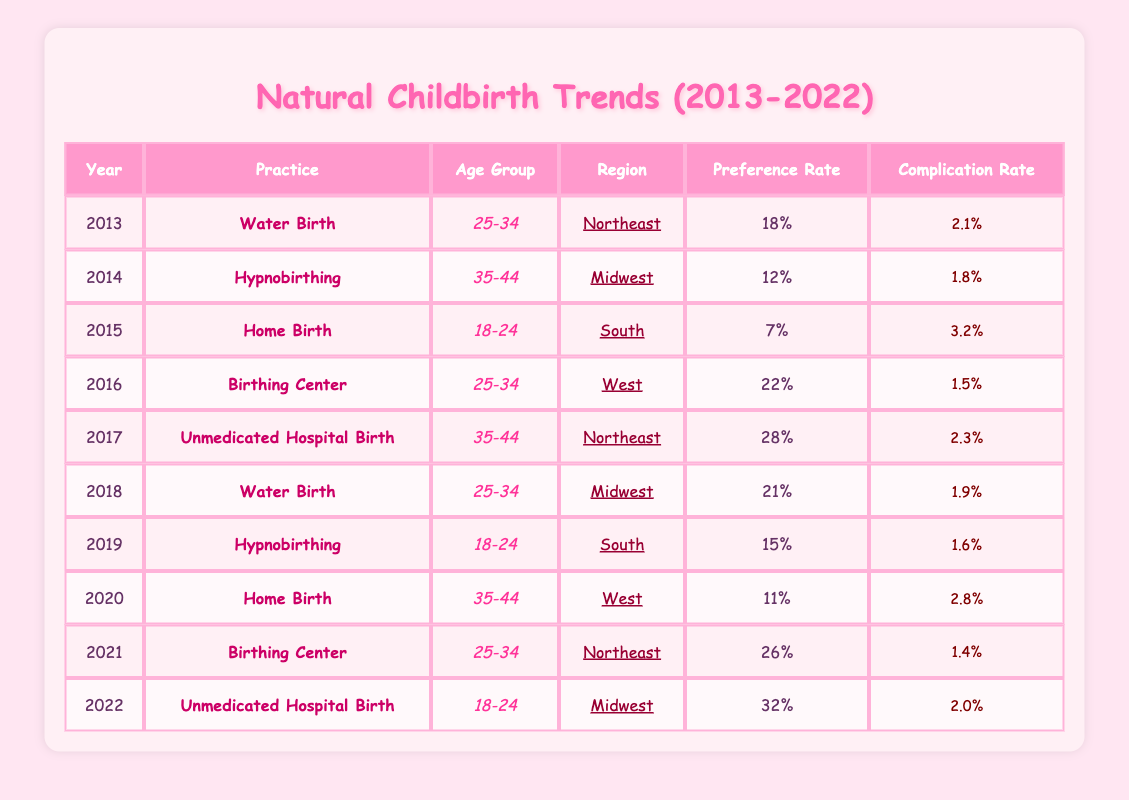What natural childbirth practice had the highest preference rate in 2022? The table shows that in 2022, the practice with the highest preference rate was Unmedicated Hospital Birth with a rate of 32.
Answer: Unmedicated Hospital Birth Which age group preferred Hypnobirthing in 2014? According to the table, Hypnobirthing was preferred by the age group 35-44 in 2014.
Answer: 35-44 How many practices had a preference rate of 20 or higher over the years? To find this, we check the preference rates for each practice from the table. The rates of 22 (2016), 28 (2017), 21 (2018), 26 (2021), and 32 (2022) qualify. This gives us a total of 5 practices.
Answer: 5 What was the complication rate for Home Birth in the year 2020? From the table, the complication rate for Home Birth in 2020 is listed as 2.8%.
Answer: 2.8% Did any of the Natural Childbirth practices show a decrease in preference rate from one year to the next? Checking the preference rates year by year, Home Birth decreased from 7 in 2015 to 11 in 2020, so that was not a decrease. However, Hypnobirthing decreased from 15 in 2019 to 12 in 2014, indicating a decrease over some years. Thus, yes, there were decreases in other practices, but none from 2015 to 2020.
Answer: Yes What was the average preference rate for Water Birth practices in the table? The preference rates for Water Birth are 18 (2013) and 21 (2018). Adding these rates gives 39, and dividing by 2 gives an average of 19.5.
Answer: 19.5 Which region had the highest complication rate for any practice in the table? By reviewing the table, we see that the highest complication rate is for Home Birth in 2015 at 3.2%, which doesn’t point to a specific region as it’s just one instance. Therefore, based on the table data, the region with the highest complication rate overall in this timeframe is the South with 3.2% for that instance.
Answer: South What was the practice with the lowest preference rate overall from 2013 to 2022? Upon reviewing the table, the practice with the lowest single preference rate is Home Birth in 2015, which had a preference rate of only 7.
Answer: Home Birth How many different natural childbirth practices were recorded from 2013 to 2022? From the table, the distinct practices listed are Water Birth, Hypnobirthing, Home Birth, Birthing Center, and Unmedicated Hospital Birth. This totals to 5 different practices.
Answer: 5 